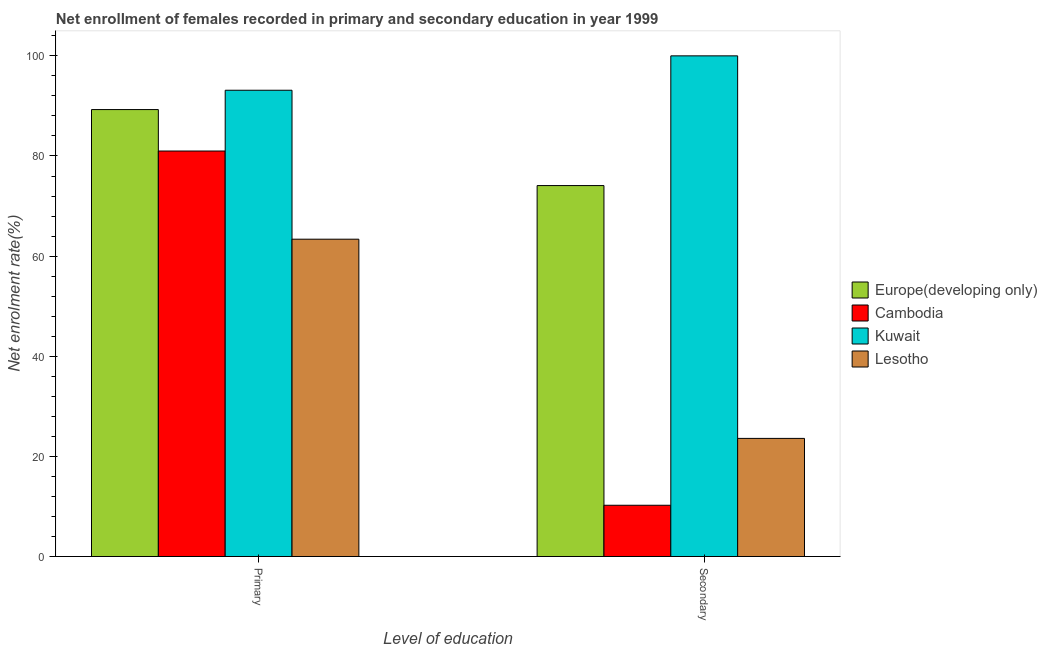How many bars are there on the 1st tick from the left?
Offer a very short reply. 4. How many bars are there on the 1st tick from the right?
Give a very brief answer. 4. What is the label of the 2nd group of bars from the left?
Your response must be concise. Secondary. What is the enrollment rate in primary education in Cambodia?
Make the answer very short. 80.99. Across all countries, what is the maximum enrollment rate in primary education?
Provide a short and direct response. 93.13. Across all countries, what is the minimum enrollment rate in secondary education?
Offer a very short reply. 10.24. In which country was the enrollment rate in primary education maximum?
Keep it short and to the point. Kuwait. In which country was the enrollment rate in secondary education minimum?
Ensure brevity in your answer.  Cambodia. What is the total enrollment rate in primary education in the graph?
Give a very brief answer. 326.78. What is the difference between the enrollment rate in secondary education in Europe(developing only) and that in Lesotho?
Keep it short and to the point. 50.5. What is the difference between the enrollment rate in primary education in Europe(developing only) and the enrollment rate in secondary education in Cambodia?
Offer a very short reply. 79.03. What is the average enrollment rate in primary education per country?
Keep it short and to the point. 81.69. What is the difference between the enrollment rate in secondary education and enrollment rate in primary education in Lesotho?
Offer a terse response. -39.79. What is the ratio of the enrollment rate in secondary education in Europe(developing only) to that in Cambodia?
Provide a succinct answer. 7.24. What does the 2nd bar from the left in Primary represents?
Offer a terse response. Cambodia. What does the 3rd bar from the right in Primary represents?
Offer a very short reply. Cambodia. How many countries are there in the graph?
Offer a very short reply. 4. Does the graph contain any zero values?
Offer a terse response. No. Does the graph contain grids?
Your answer should be compact. No. Where does the legend appear in the graph?
Ensure brevity in your answer.  Center right. What is the title of the graph?
Keep it short and to the point. Net enrollment of females recorded in primary and secondary education in year 1999. Does "Ukraine" appear as one of the legend labels in the graph?
Your answer should be very brief. No. What is the label or title of the X-axis?
Give a very brief answer. Level of education. What is the label or title of the Y-axis?
Ensure brevity in your answer.  Net enrolment rate(%). What is the Net enrolment rate(%) of Europe(developing only) in Primary?
Ensure brevity in your answer.  89.27. What is the Net enrolment rate(%) of Cambodia in Primary?
Make the answer very short. 80.99. What is the Net enrolment rate(%) in Kuwait in Primary?
Your answer should be compact. 93.13. What is the Net enrolment rate(%) of Lesotho in Primary?
Your answer should be compact. 63.38. What is the Net enrolment rate(%) of Europe(developing only) in Secondary?
Provide a short and direct response. 74.09. What is the Net enrolment rate(%) in Cambodia in Secondary?
Your response must be concise. 10.24. What is the Net enrolment rate(%) of Lesotho in Secondary?
Your response must be concise. 23.59. Across all Level of education, what is the maximum Net enrolment rate(%) of Europe(developing only)?
Provide a succinct answer. 89.27. Across all Level of education, what is the maximum Net enrolment rate(%) of Cambodia?
Ensure brevity in your answer.  80.99. Across all Level of education, what is the maximum Net enrolment rate(%) in Kuwait?
Offer a very short reply. 100. Across all Level of education, what is the maximum Net enrolment rate(%) of Lesotho?
Make the answer very short. 63.38. Across all Level of education, what is the minimum Net enrolment rate(%) in Europe(developing only)?
Provide a short and direct response. 74.09. Across all Level of education, what is the minimum Net enrolment rate(%) of Cambodia?
Offer a very short reply. 10.24. Across all Level of education, what is the minimum Net enrolment rate(%) of Kuwait?
Your response must be concise. 93.13. Across all Level of education, what is the minimum Net enrolment rate(%) of Lesotho?
Offer a very short reply. 23.59. What is the total Net enrolment rate(%) in Europe(developing only) in the graph?
Give a very brief answer. 163.36. What is the total Net enrolment rate(%) in Cambodia in the graph?
Provide a short and direct response. 91.23. What is the total Net enrolment rate(%) in Kuwait in the graph?
Your answer should be very brief. 193.13. What is the total Net enrolment rate(%) in Lesotho in the graph?
Your answer should be very brief. 86.98. What is the difference between the Net enrolment rate(%) in Europe(developing only) in Primary and that in Secondary?
Your response must be concise. 15.18. What is the difference between the Net enrolment rate(%) in Cambodia in Primary and that in Secondary?
Provide a short and direct response. 70.75. What is the difference between the Net enrolment rate(%) in Kuwait in Primary and that in Secondary?
Provide a succinct answer. -6.87. What is the difference between the Net enrolment rate(%) of Lesotho in Primary and that in Secondary?
Your answer should be compact. 39.79. What is the difference between the Net enrolment rate(%) of Europe(developing only) in Primary and the Net enrolment rate(%) of Cambodia in Secondary?
Your response must be concise. 79.03. What is the difference between the Net enrolment rate(%) of Europe(developing only) in Primary and the Net enrolment rate(%) of Kuwait in Secondary?
Your answer should be very brief. -10.73. What is the difference between the Net enrolment rate(%) of Europe(developing only) in Primary and the Net enrolment rate(%) of Lesotho in Secondary?
Your answer should be compact. 65.68. What is the difference between the Net enrolment rate(%) in Cambodia in Primary and the Net enrolment rate(%) in Kuwait in Secondary?
Offer a terse response. -19.01. What is the difference between the Net enrolment rate(%) of Cambodia in Primary and the Net enrolment rate(%) of Lesotho in Secondary?
Give a very brief answer. 57.4. What is the difference between the Net enrolment rate(%) in Kuwait in Primary and the Net enrolment rate(%) in Lesotho in Secondary?
Your answer should be compact. 69.54. What is the average Net enrolment rate(%) in Europe(developing only) per Level of education?
Provide a succinct answer. 81.68. What is the average Net enrolment rate(%) in Cambodia per Level of education?
Offer a terse response. 45.61. What is the average Net enrolment rate(%) of Kuwait per Level of education?
Offer a terse response. 96.57. What is the average Net enrolment rate(%) of Lesotho per Level of education?
Offer a very short reply. 43.49. What is the difference between the Net enrolment rate(%) in Europe(developing only) and Net enrolment rate(%) in Cambodia in Primary?
Keep it short and to the point. 8.28. What is the difference between the Net enrolment rate(%) of Europe(developing only) and Net enrolment rate(%) of Kuwait in Primary?
Keep it short and to the point. -3.86. What is the difference between the Net enrolment rate(%) of Europe(developing only) and Net enrolment rate(%) of Lesotho in Primary?
Offer a terse response. 25.89. What is the difference between the Net enrolment rate(%) of Cambodia and Net enrolment rate(%) of Kuwait in Primary?
Offer a terse response. -12.14. What is the difference between the Net enrolment rate(%) of Cambodia and Net enrolment rate(%) of Lesotho in Primary?
Keep it short and to the point. 17.61. What is the difference between the Net enrolment rate(%) in Kuwait and Net enrolment rate(%) in Lesotho in Primary?
Your answer should be compact. 29.75. What is the difference between the Net enrolment rate(%) in Europe(developing only) and Net enrolment rate(%) in Cambodia in Secondary?
Your answer should be compact. 63.85. What is the difference between the Net enrolment rate(%) in Europe(developing only) and Net enrolment rate(%) in Kuwait in Secondary?
Your response must be concise. -25.91. What is the difference between the Net enrolment rate(%) of Europe(developing only) and Net enrolment rate(%) of Lesotho in Secondary?
Give a very brief answer. 50.5. What is the difference between the Net enrolment rate(%) of Cambodia and Net enrolment rate(%) of Kuwait in Secondary?
Ensure brevity in your answer.  -89.76. What is the difference between the Net enrolment rate(%) of Cambodia and Net enrolment rate(%) of Lesotho in Secondary?
Offer a very short reply. -13.36. What is the difference between the Net enrolment rate(%) in Kuwait and Net enrolment rate(%) in Lesotho in Secondary?
Ensure brevity in your answer.  76.41. What is the ratio of the Net enrolment rate(%) of Europe(developing only) in Primary to that in Secondary?
Make the answer very short. 1.2. What is the ratio of the Net enrolment rate(%) of Cambodia in Primary to that in Secondary?
Your response must be concise. 7.91. What is the ratio of the Net enrolment rate(%) in Kuwait in Primary to that in Secondary?
Make the answer very short. 0.93. What is the ratio of the Net enrolment rate(%) in Lesotho in Primary to that in Secondary?
Your response must be concise. 2.69. What is the difference between the highest and the second highest Net enrolment rate(%) of Europe(developing only)?
Make the answer very short. 15.18. What is the difference between the highest and the second highest Net enrolment rate(%) of Cambodia?
Offer a terse response. 70.75. What is the difference between the highest and the second highest Net enrolment rate(%) of Kuwait?
Offer a very short reply. 6.87. What is the difference between the highest and the second highest Net enrolment rate(%) of Lesotho?
Your answer should be compact. 39.79. What is the difference between the highest and the lowest Net enrolment rate(%) in Europe(developing only)?
Offer a terse response. 15.18. What is the difference between the highest and the lowest Net enrolment rate(%) of Cambodia?
Keep it short and to the point. 70.75. What is the difference between the highest and the lowest Net enrolment rate(%) of Kuwait?
Offer a very short reply. 6.87. What is the difference between the highest and the lowest Net enrolment rate(%) of Lesotho?
Provide a succinct answer. 39.79. 